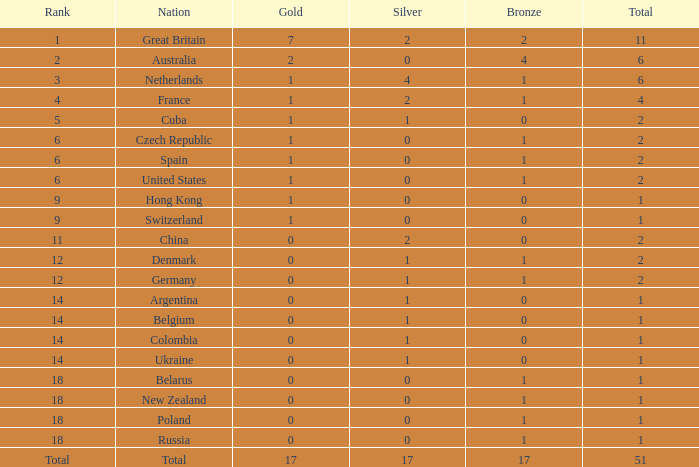Tell me the lowest gold for rank of 6 and total less than 2 None. Can you give me this table as a dict? {'header': ['Rank', 'Nation', 'Gold', 'Silver', 'Bronze', 'Total'], 'rows': [['1', 'Great Britain', '7', '2', '2', '11'], ['2', 'Australia', '2', '0', '4', '6'], ['3', 'Netherlands', '1', '4', '1', '6'], ['4', 'France', '1', '2', '1', '4'], ['5', 'Cuba', '1', '1', '0', '2'], ['6', 'Czech Republic', '1', '0', '1', '2'], ['6', 'Spain', '1', '0', '1', '2'], ['6', 'United States', '1', '0', '1', '2'], ['9', 'Hong Kong', '1', '0', '0', '1'], ['9', 'Switzerland', '1', '0', '0', '1'], ['11', 'China', '0', '2', '0', '2'], ['12', 'Denmark', '0', '1', '1', '2'], ['12', 'Germany', '0', '1', '1', '2'], ['14', 'Argentina', '0', '1', '0', '1'], ['14', 'Belgium', '0', '1', '0', '1'], ['14', 'Colombia', '0', '1', '0', '1'], ['14', 'Ukraine', '0', '1', '0', '1'], ['18', 'Belarus', '0', '0', '1', '1'], ['18', 'New Zealand', '0', '0', '1', '1'], ['18', 'Poland', '0', '0', '1', '1'], ['18', 'Russia', '0', '0', '1', '1'], ['Total', 'Total', '17', '17', '17', '51']]} 